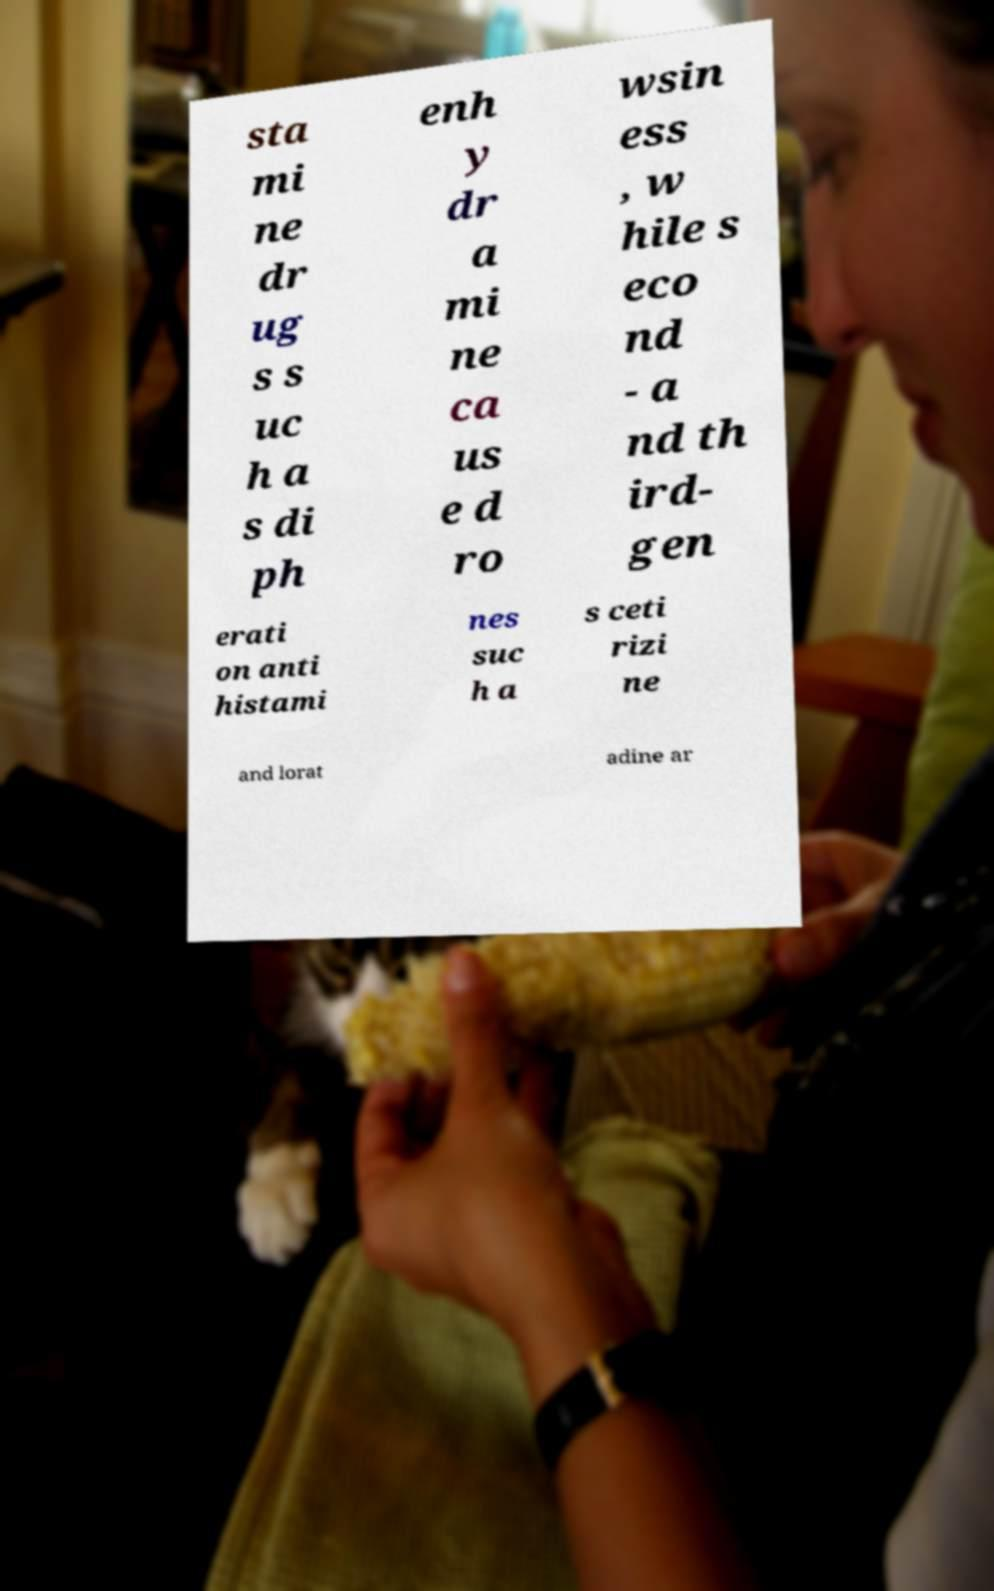I need the written content from this picture converted into text. Can you do that? sta mi ne dr ug s s uc h a s di ph enh y dr a mi ne ca us e d ro wsin ess , w hile s eco nd - a nd th ird- gen erati on anti histami nes suc h a s ceti rizi ne and lorat adine ar 